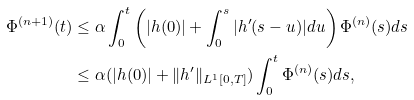Convert formula to latex. <formula><loc_0><loc_0><loc_500><loc_500>\Phi ^ { ( n + 1 ) } ( t ) & \leq \alpha \int _ { 0 } ^ { t } \left ( | h ( 0 ) | + \int _ { 0 } ^ { s } | h ^ { \prime } ( s - u ) | d u \right ) \Phi ^ { ( n ) } ( s ) d s \\ & \leq \alpha ( | h ( 0 ) | + \| h ^ { \prime } \| _ { L ^ { 1 } [ 0 , T ] } ) \int _ { 0 } ^ { t } \Phi ^ { ( n ) } ( s ) d s ,</formula> 